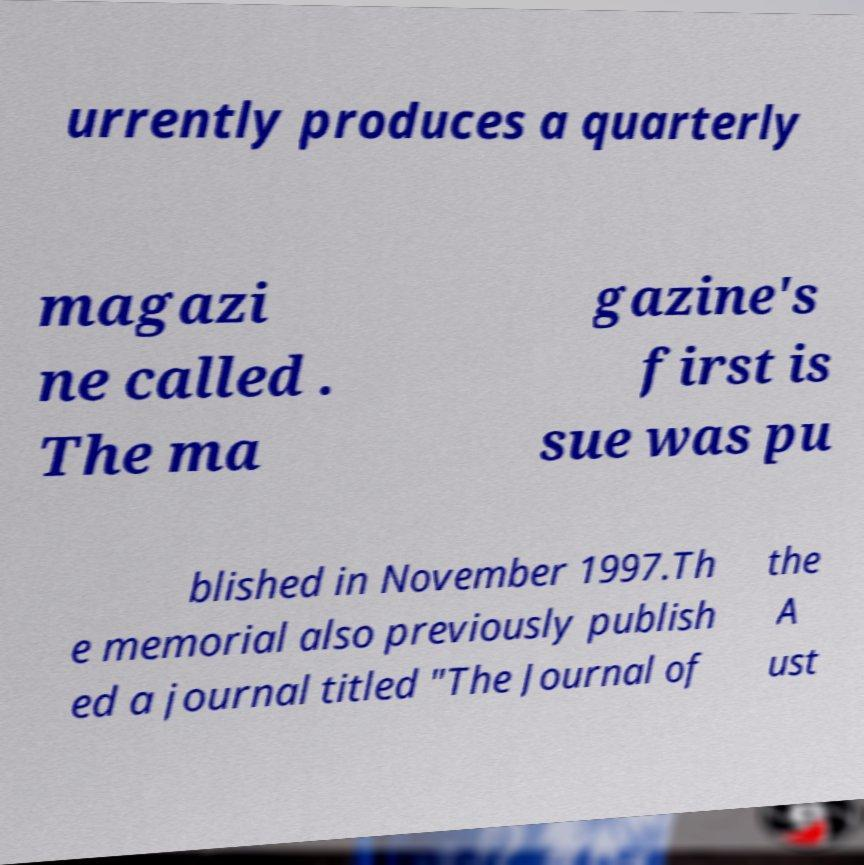Could you extract and type out the text from this image? urrently produces a quarterly magazi ne called . The ma gazine's first is sue was pu blished in November 1997.Th e memorial also previously publish ed a journal titled "The Journal of the A ust 